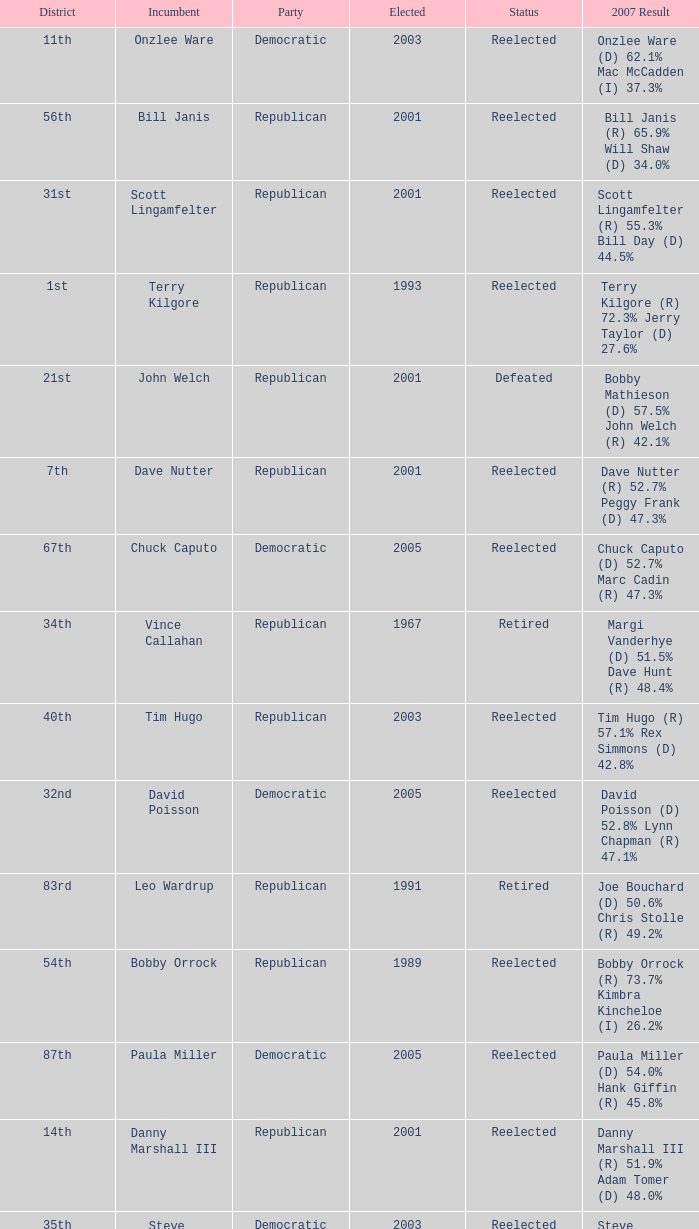What district is incument terry kilgore from? 1st. 